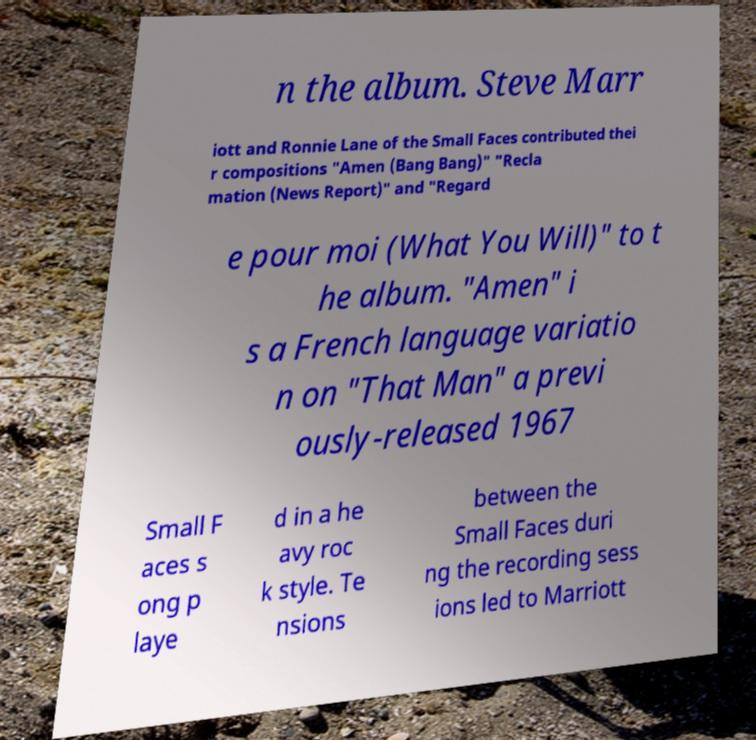What messages or text are displayed in this image? I need them in a readable, typed format. n the album. Steve Marr iott and Ronnie Lane of the Small Faces contributed thei r compositions "Amen (Bang Bang)" "Recla mation (News Report)" and "Regard e pour moi (What You Will)" to t he album. "Amen" i s a French language variatio n on "That Man" a previ ously-released 1967 Small F aces s ong p laye d in a he avy roc k style. Te nsions between the Small Faces duri ng the recording sess ions led to Marriott 